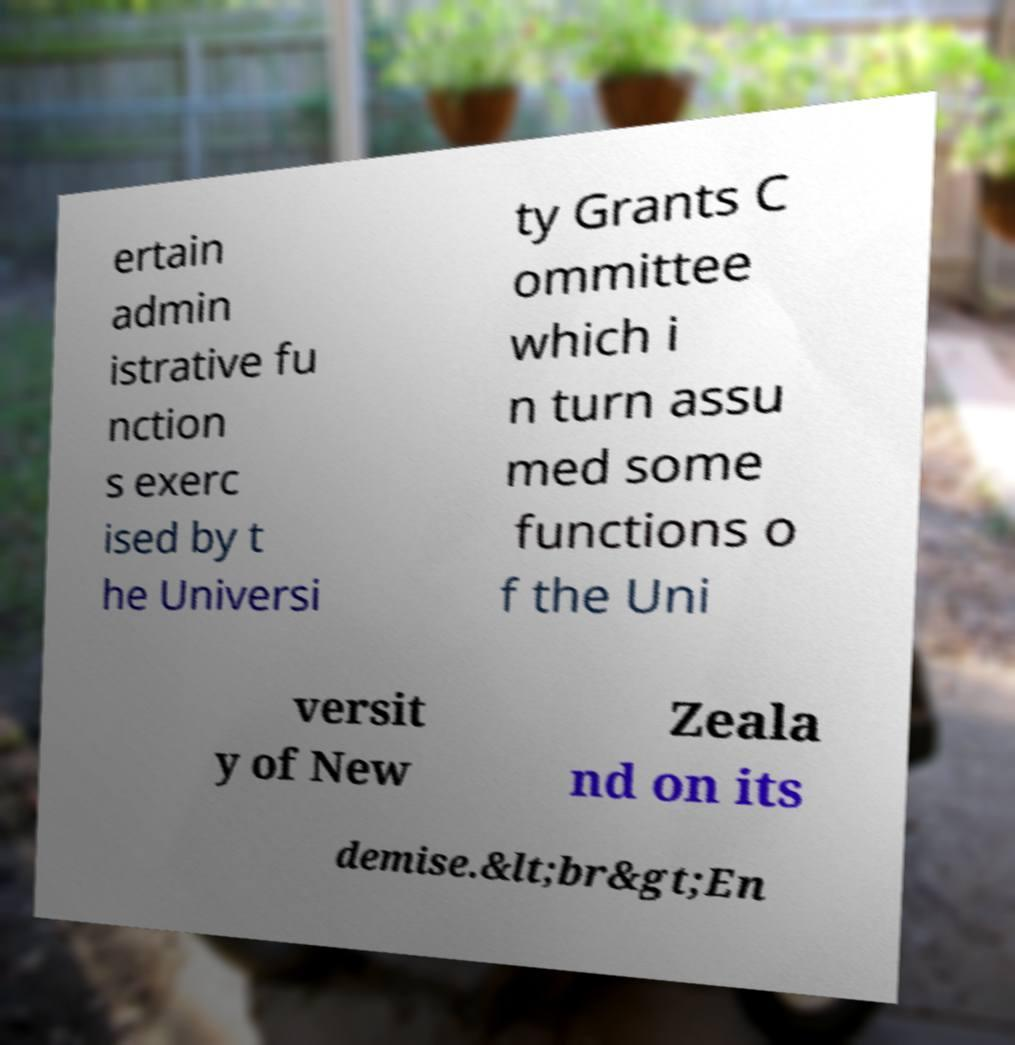There's text embedded in this image that I need extracted. Can you transcribe it verbatim? ertain admin istrative fu nction s exerc ised by t he Universi ty Grants C ommittee which i n turn assu med some functions o f the Uni versit y of New Zeala nd on its demise.&lt;br&gt;En 